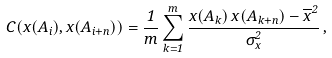Convert formula to latex. <formula><loc_0><loc_0><loc_500><loc_500>C ( x ( A _ { i } ) , x ( A _ { i + n } ) ) = \frac { 1 } { m } \sum _ { k = 1 } ^ { m } \frac { x ( A _ { k } ) \, x ( A _ { k + n } ) - \overline { x } ^ { 2 } } { \sigma _ { x } ^ { 2 } } \, ,</formula> 